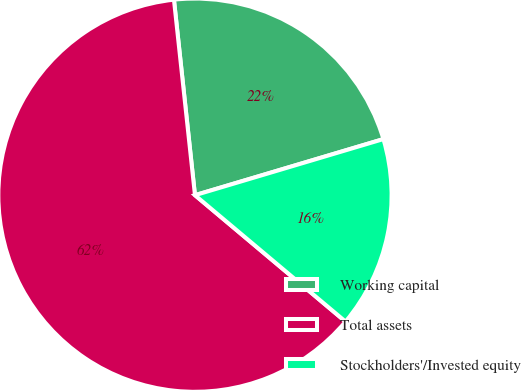Convert chart to OTSL. <chart><loc_0><loc_0><loc_500><loc_500><pie_chart><fcel>Working capital<fcel>Total assets<fcel>Stockholders'/Invested equity<nl><fcel>22.1%<fcel>62.18%<fcel>15.72%<nl></chart> 